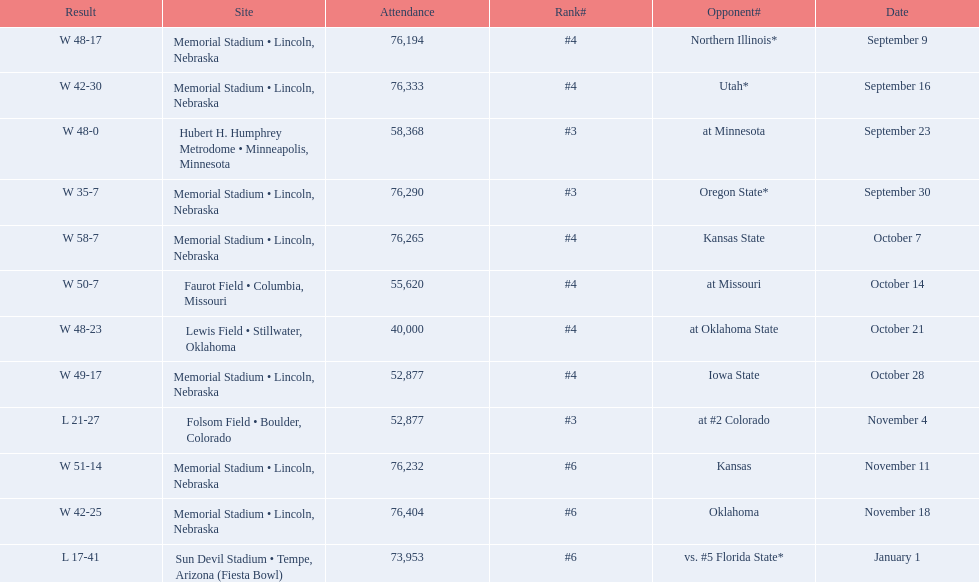When did nebraska play oregon state? September 30. What was the attendance at the september 30 game? 76,290. 